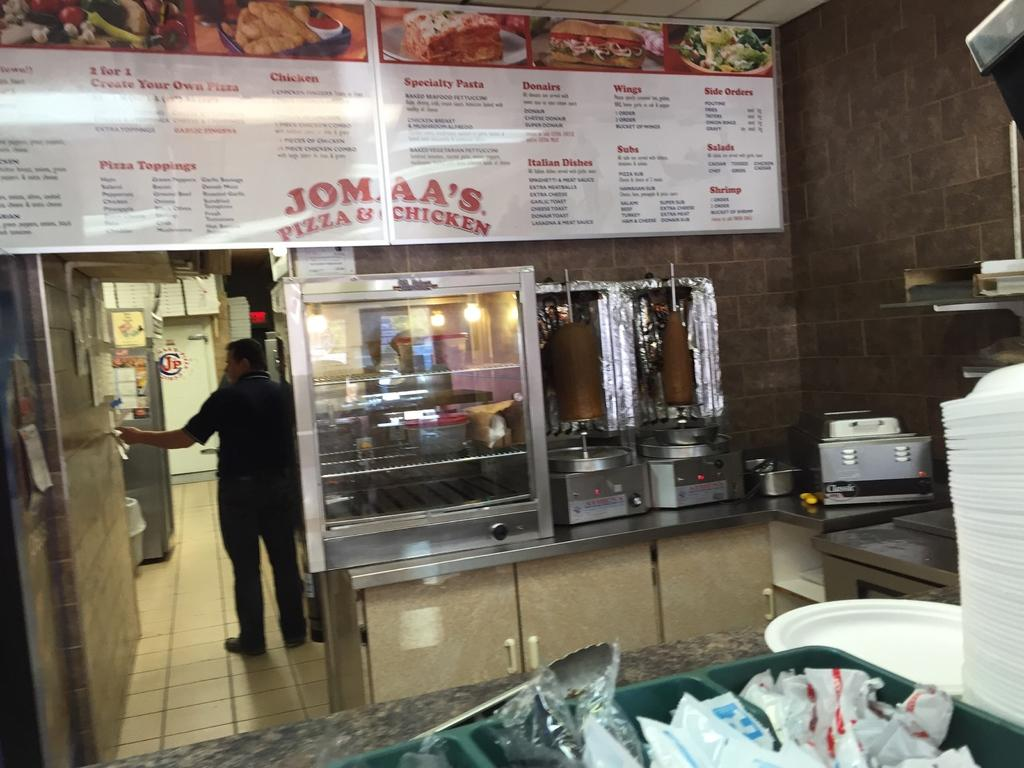<image>
Provide a brief description of the given image. The front counter of Jomaa's Pizza & Chicken below the menu. 